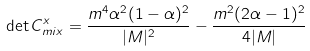Convert formula to latex. <formula><loc_0><loc_0><loc_500><loc_500>\det C ^ { x } _ { m i x } = \frac { m ^ { 4 } \alpha ^ { 2 } ( 1 - \alpha ) ^ { 2 } } { | M | ^ { 2 } } - \frac { m ^ { 2 } ( 2 \alpha - 1 ) ^ { 2 } } { 4 | M | }</formula> 